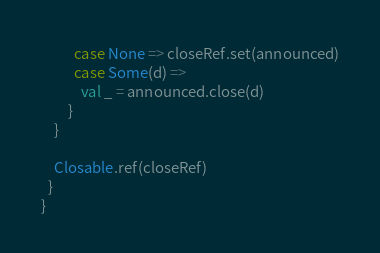Convert code to text. <code><loc_0><loc_0><loc_500><loc_500><_Scala_>          case None => closeRef.set(announced)
          case Some(d) =>
            val _ = announced.close(d)
        }
    }

    Closable.ref(closeRef)
  }
}
</code> 